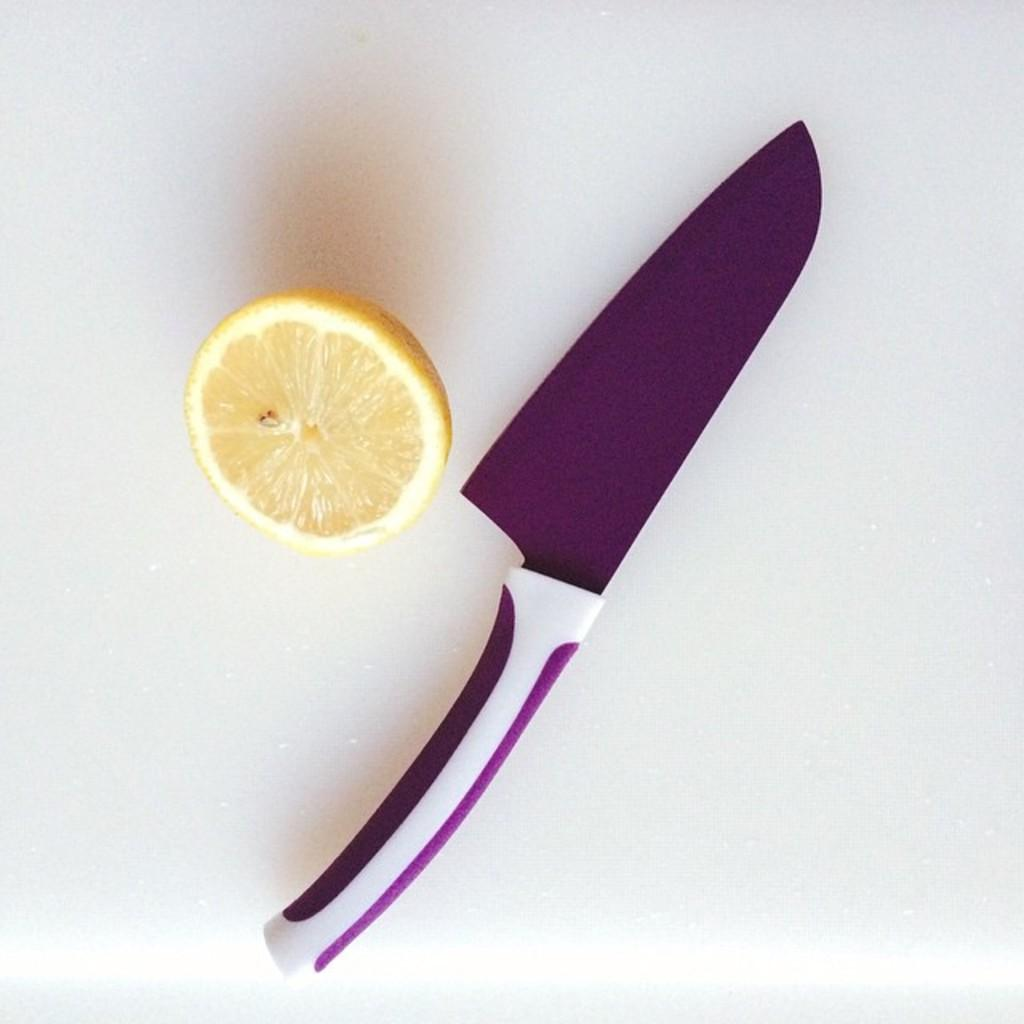What object is present in the image that can be used for cutting? There is a knife in the image that can be used for cutting. What fruit is visible in the image? There is a lemon in the image. Where are the knife and lemon located in the image? The knife and lemon are on a table. How many quilts are being used to cover the lemon in the image? There are no quilts present in the image, and the lemon is not being covered. What type of sugar is being used to sweeten the knife in the image? There is no sugar present in the image, and the knife is not being sweetened. 